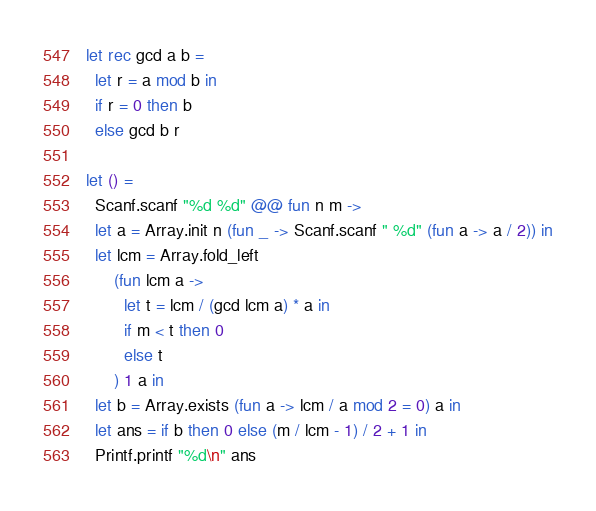<code> <loc_0><loc_0><loc_500><loc_500><_OCaml_>let rec gcd a b =
  let r = a mod b in
  if r = 0 then b
  else gcd b r

let () =
  Scanf.scanf "%d %d" @@ fun n m ->
  let a = Array.init n (fun _ -> Scanf.scanf " %d" (fun a -> a / 2)) in
  let lcm = Array.fold_left
      (fun lcm a ->
        let t = lcm / (gcd lcm a) * a in
        if m < t then 0
        else t
      ) 1 a in
  let b = Array.exists (fun a -> lcm / a mod 2 = 0) a in
  let ans = if b then 0 else (m / lcm - 1) / 2 + 1 in
  Printf.printf "%d\n" ans
</code> 